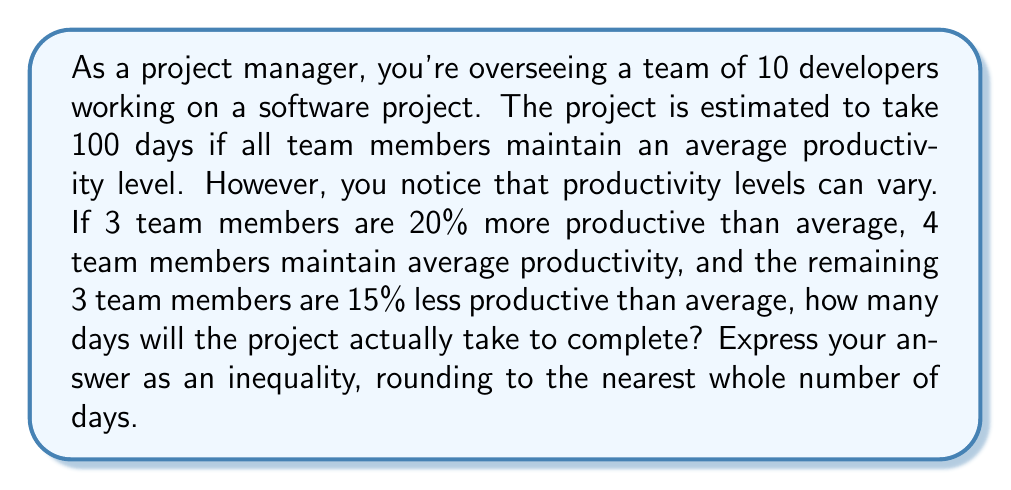Solve this math problem. Let's approach this step-by-step:

1) First, let's calculate the total productivity of the team in terms of "average developer days":

   - 3 developers at 120% productivity: $3 \times 1.20 = 3.60$
   - 4 developers at 100% productivity: $4 \times 1.00 = 4.00$
   - 3 developers at 85% productivity: $3 \times 0.85 = 2.55$

   Total productivity: $3.60 + 4.00 + 2.55 = 10.15$ "average developer days" per actual day

2) If the project would take 100 days with 10 average developers, that means the total work is equivalent to 1000 "average developer days".

3) To find how long the project will actually take, we divide the total work by the daily productivity:

   $\text{Actual days} = \frac{1000 \text{ average developer days}}{10.15 \text{ average developer days per actual day}} \approx 98.52 \text{ days}$

4) Rounding to the nearest whole number: 99 days

5) To express this as an inequality, we can say the project will take less than or equal to 99 days:

   $\text{Project duration} \leq 99 \text{ days}$
Answer: $\text{Project duration} \leq 99 \text{ days}$ 